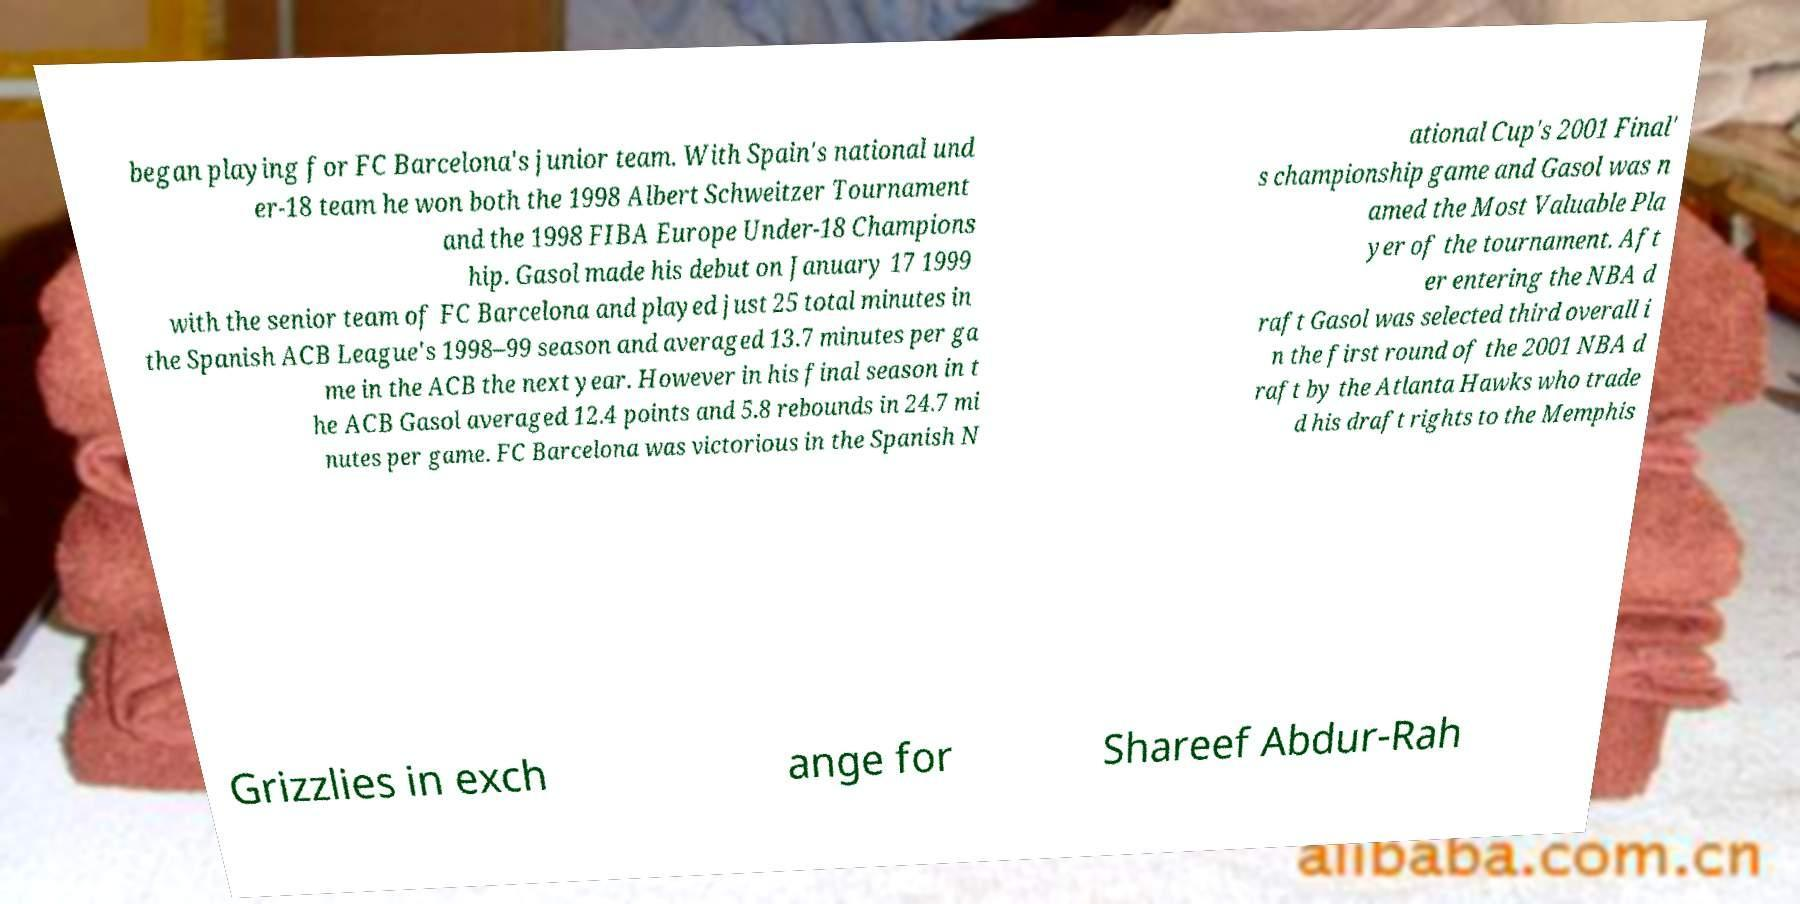Please read and relay the text visible in this image. What does it say? began playing for FC Barcelona's junior team. With Spain's national und er-18 team he won both the 1998 Albert Schweitzer Tournament and the 1998 FIBA Europe Under-18 Champions hip. Gasol made his debut on January 17 1999 with the senior team of FC Barcelona and played just 25 total minutes in the Spanish ACB League's 1998–99 season and averaged 13.7 minutes per ga me in the ACB the next year. However in his final season in t he ACB Gasol averaged 12.4 points and 5.8 rebounds in 24.7 mi nutes per game. FC Barcelona was victorious in the Spanish N ational Cup's 2001 Final' s championship game and Gasol was n amed the Most Valuable Pla yer of the tournament. Aft er entering the NBA d raft Gasol was selected third overall i n the first round of the 2001 NBA d raft by the Atlanta Hawks who trade d his draft rights to the Memphis Grizzlies in exch ange for Shareef Abdur-Rah 